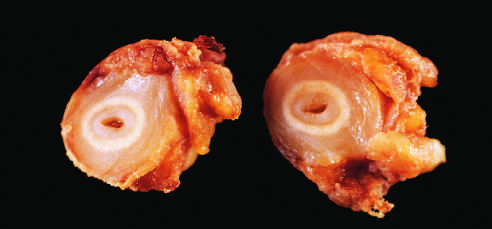what is the area of intimal hyperplasia?
Answer the question using a single word or phrase. The inner core of tan tissue 